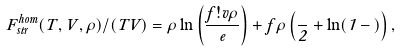<formula> <loc_0><loc_0><loc_500><loc_500>F _ { s t r } ^ { h o m } ( T , V , \rho ) / ( T V ) = \rho \ln \left ( \frac { f ! v \rho } { e } \right ) + f \rho \left ( \frac { \Gamma } { 2 } + \ln ( 1 - \Gamma ) \right ) ,</formula> 